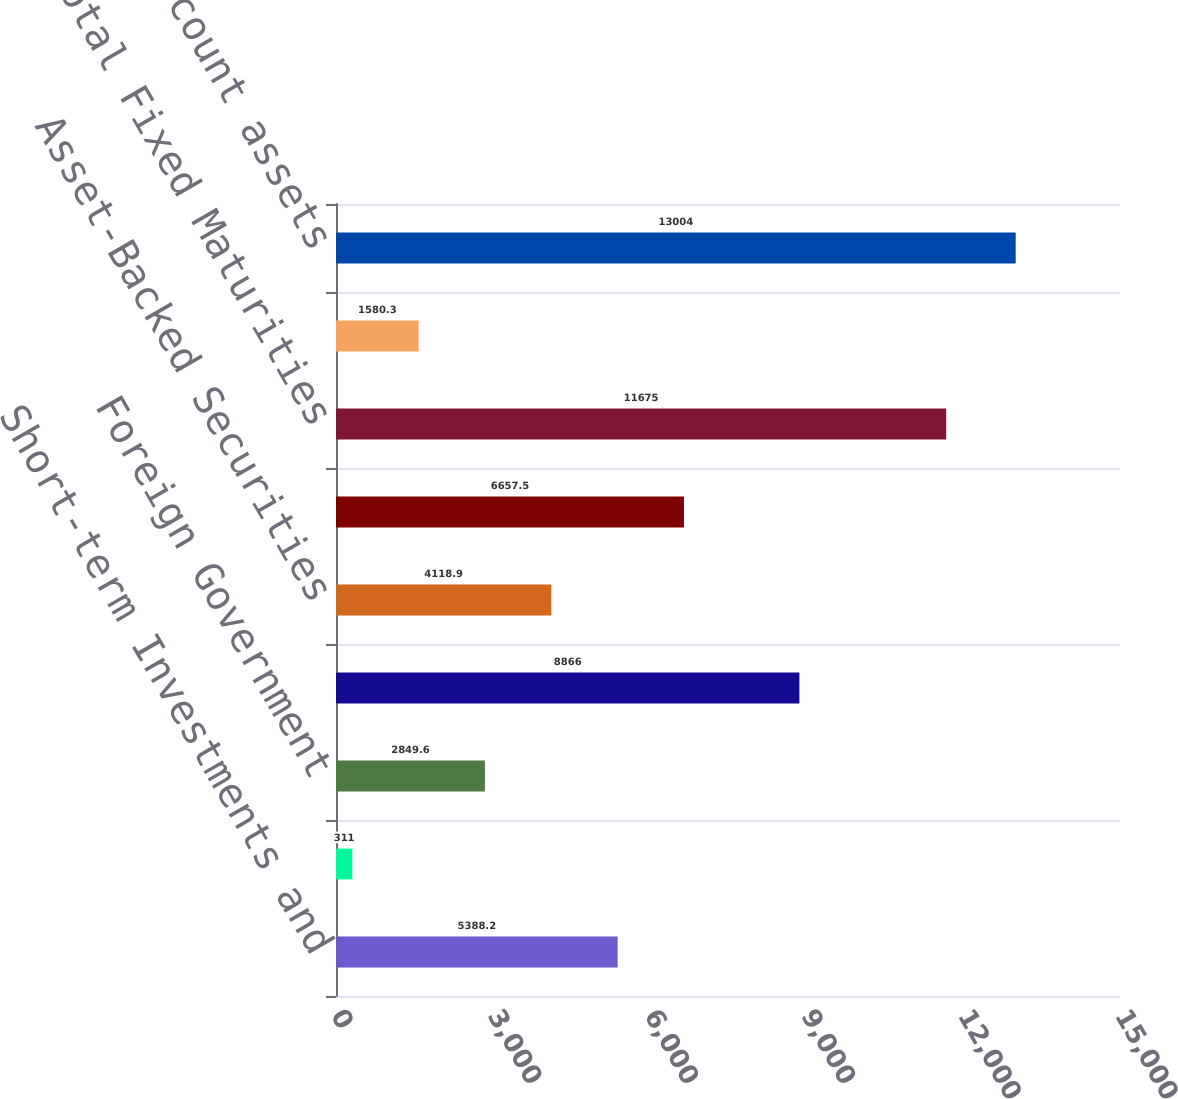Convert chart. <chart><loc_0><loc_0><loc_500><loc_500><bar_chart><fcel>Short-term Investments and<fcel>US Government<fcel>Foreign Government<fcel>Corporate Securities<fcel>Asset-Backed Securities<fcel>Mortgage Backed<fcel>Total Fixed Maturities<fcel>Equity Securities<fcel>Total trading account assets<nl><fcel>5388.2<fcel>311<fcel>2849.6<fcel>8866<fcel>4118.9<fcel>6657.5<fcel>11675<fcel>1580.3<fcel>13004<nl></chart> 